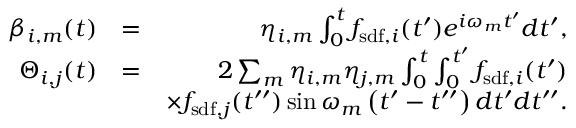<formula> <loc_0><loc_0><loc_500><loc_500>\begin{array} { r l r } { \beta _ { i , m } ( t ) } & { = } & { \eta _ { i , m } \int _ { 0 } ^ { t } f _ { s d f , i } ( t ^ { \prime } ) e ^ { i \omega _ { m } t ^ { \prime } } d t ^ { \prime } , } \\ { \Theta _ { i , j } ( t ) } & { = } & { 2 \sum _ { m } \eta _ { i , m } \eta _ { j , m } \int _ { 0 } ^ { t } \int _ { 0 } ^ { t ^ { \prime } } f _ { s d f , i } ( t ^ { \prime } ) } \\ & { \times f _ { s d f , j } ( t ^ { \prime \prime } ) \sin \omega _ { m } \left ( t ^ { \prime } - t ^ { \prime \prime } \right ) d t ^ { \prime } d t ^ { \prime \prime } . } \end{array}</formula> 